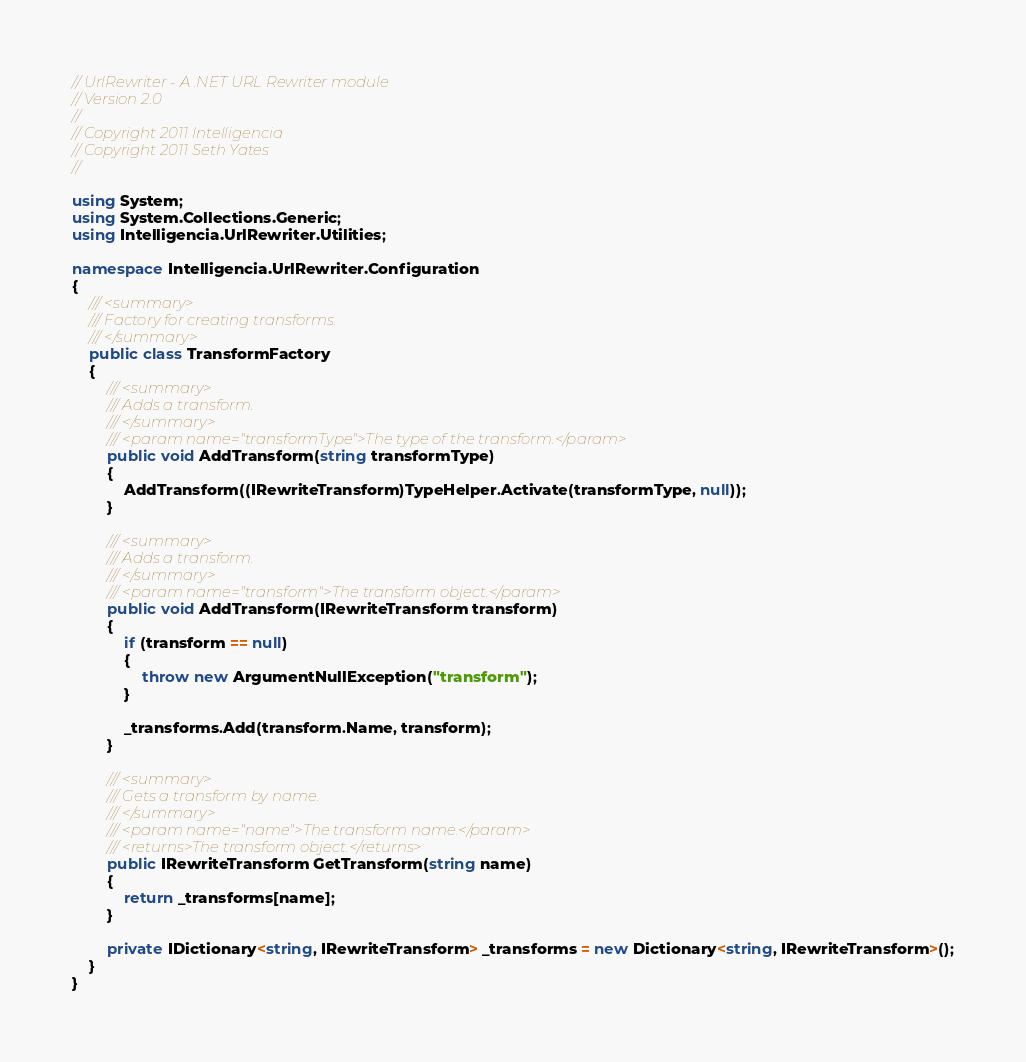<code> <loc_0><loc_0><loc_500><loc_500><_C#_>// UrlRewriter - A .NET URL Rewriter module
// Version 2.0
//
// Copyright 2011 Intelligencia
// Copyright 2011 Seth Yates
// 

using System;
using System.Collections.Generic;
using Intelligencia.UrlRewriter.Utilities;

namespace Intelligencia.UrlRewriter.Configuration
{
    /// <summary>
    /// Factory for creating transforms.
    /// </summary>
    public class TransformFactory
    {
        /// <summary>
        /// Adds a transform.
        /// </summary>
        /// <param name="transformType">The type of the transform.</param>
        public void AddTransform(string transformType)
        {
            AddTransform((IRewriteTransform)TypeHelper.Activate(transformType, null));
        }

        /// <summary>
        /// Adds a transform.
        /// </summary>
        /// <param name="transform">The transform object.</param>
        public void AddTransform(IRewriteTransform transform)
        {
            if (transform == null)
            {
                throw new ArgumentNullException("transform");
            }

            _transforms.Add(transform.Name, transform);
        }

        /// <summary>
        /// Gets a transform by name.
        /// </summary>
        /// <param name="name">The transform name.</param>
        /// <returns>The transform object.</returns>
        public IRewriteTransform GetTransform(string name)
        {
            return _transforms[name];
        }

        private IDictionary<string, IRewriteTransform> _transforms = new Dictionary<string, IRewriteTransform>();
    }
}
</code> 